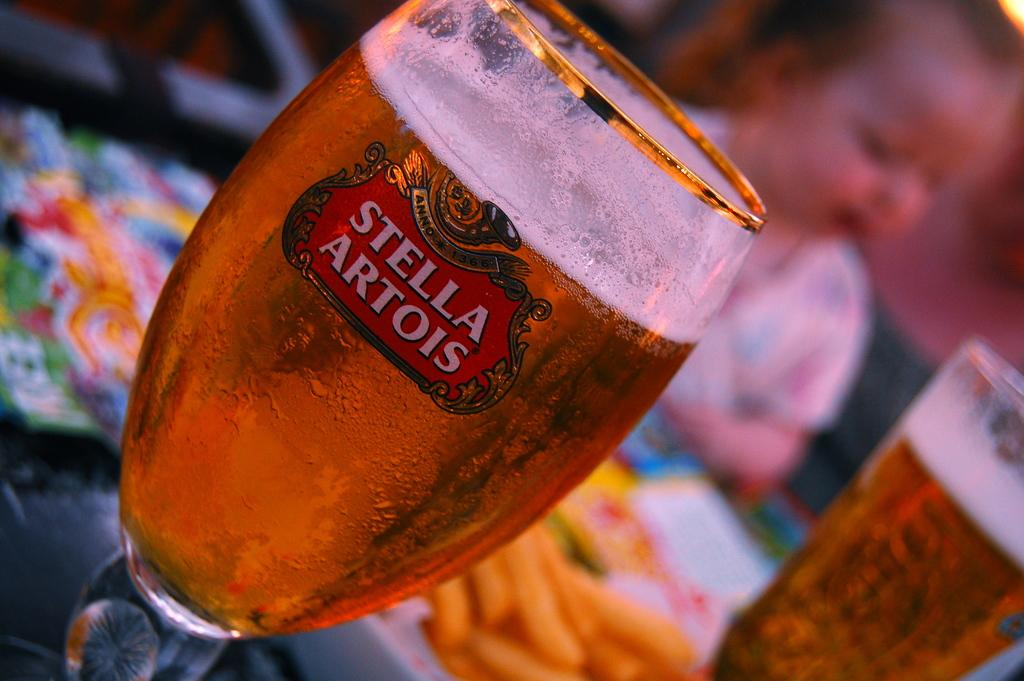<image>
Present a compact description of the photo's key features. A glass of beer that says Stella Artois on it's side. 